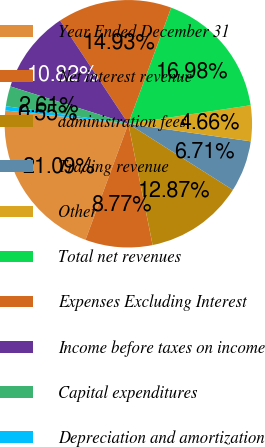Convert chart to OTSL. <chart><loc_0><loc_0><loc_500><loc_500><pie_chart><fcel>Year Ended December 31<fcel>Net interest revenue<fcel>administration fees<fcel>Trading revenue<fcel>Other<fcel>Total net revenues<fcel>Expenses Excluding Interest<fcel>Income before taxes on income<fcel>Capital expenditures<fcel>Depreciation and amortization<nl><fcel>21.09%<fcel>8.77%<fcel>12.87%<fcel>6.71%<fcel>4.66%<fcel>16.98%<fcel>14.93%<fcel>10.82%<fcel>2.61%<fcel>0.55%<nl></chart> 